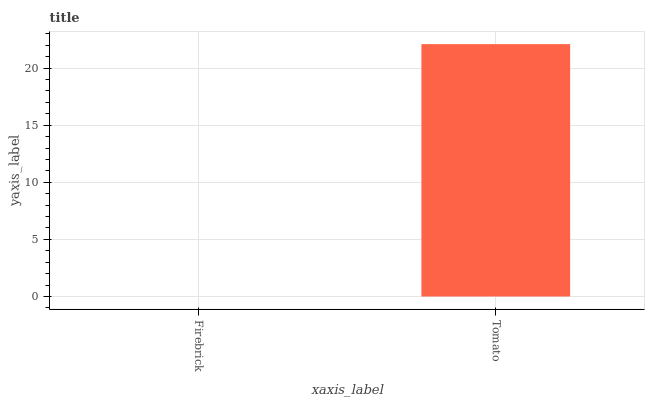Is Tomato the minimum?
Answer yes or no. No. Is Tomato greater than Firebrick?
Answer yes or no. Yes. Is Firebrick less than Tomato?
Answer yes or no. Yes. Is Firebrick greater than Tomato?
Answer yes or no. No. Is Tomato less than Firebrick?
Answer yes or no. No. Is Tomato the high median?
Answer yes or no. Yes. Is Firebrick the low median?
Answer yes or no. Yes. Is Firebrick the high median?
Answer yes or no. No. Is Tomato the low median?
Answer yes or no. No. 